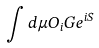<formula> <loc_0><loc_0><loc_500><loc_500>\int d \mu O _ { i } G e ^ { i S }</formula> 